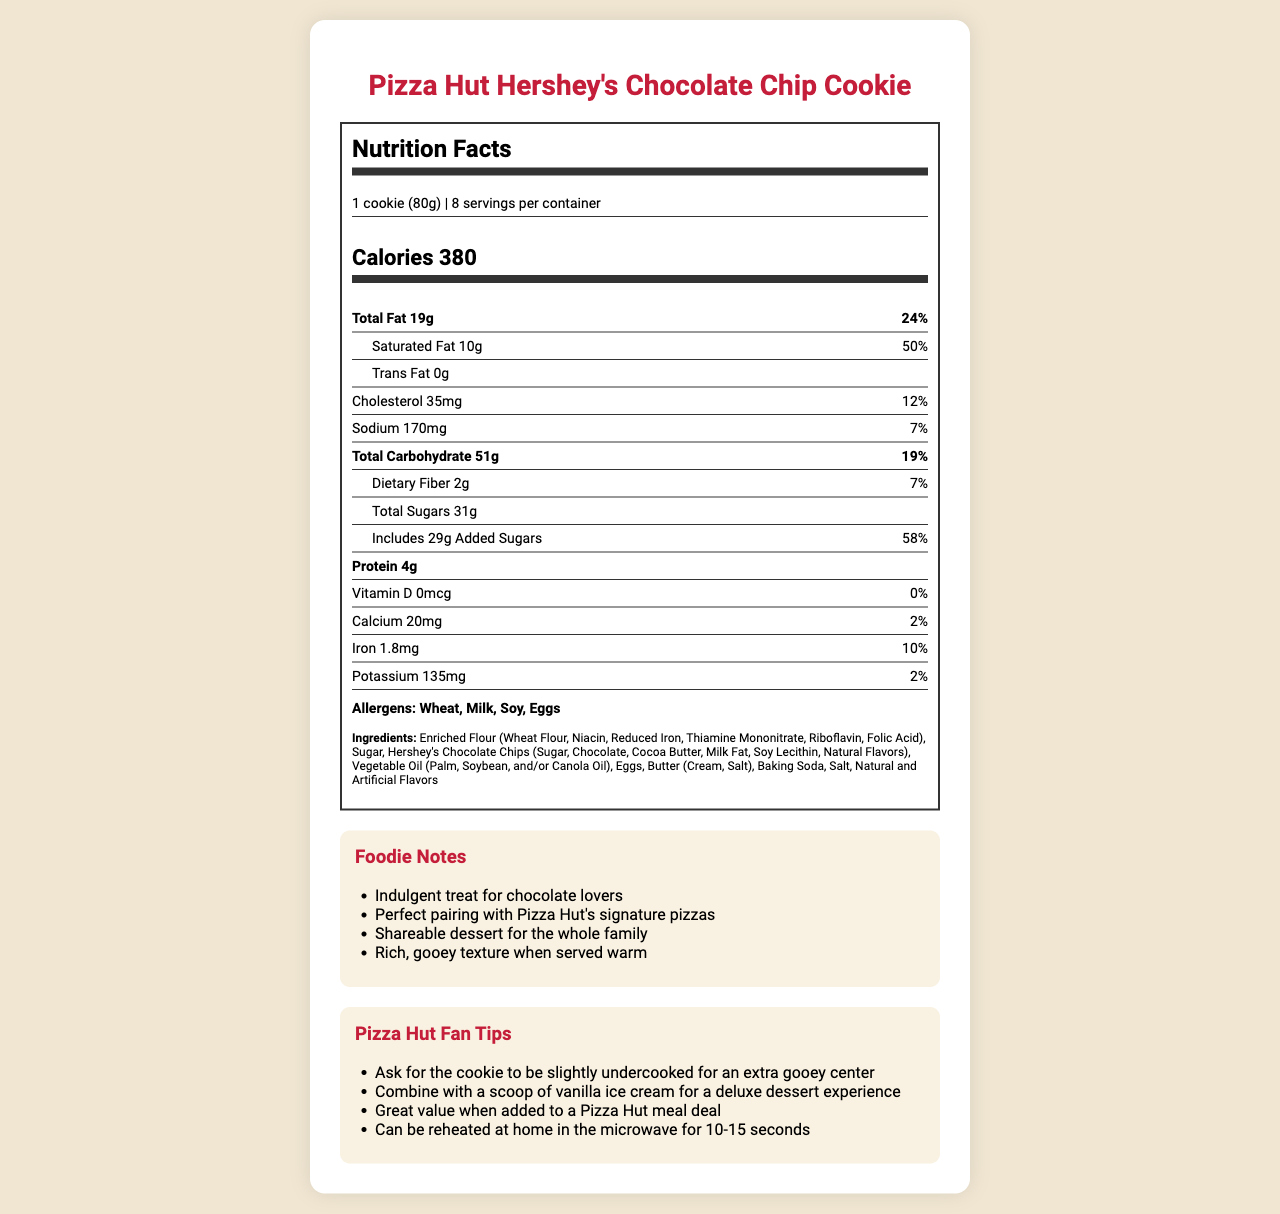what is the serving size for Pizza Hut Hershey's Chocolate Chip Cookie? The serving size is stated in the serving info section at the beginning of the document.
Answer: 1 cookie (80g) how many calories are in one serving of Pizza Hut Hershey's Chocolate Chip Cookie? The calorie information is prominently displayed below the serving size section.
Answer: 380 what is the total fat content in one serving? The total fat content is mentioned in the Total Fat nutrient info section.
Answer: 19g what percentage of the daily value is the saturated fat in one serving? The daily value percentage for saturated fat is listed right next to its amount under the Total Fat section.
Answer: 50% how much protein is in one serving of the cookie? The protein content is listed under the bold nutrient info section.
Answer: 4g what are the allergens listed for Pizza Hut Hershey's Chocolate Chip Cookie? The allergens are stated in the allergens section towards the bottom of the nutrition label.
Answer: Wheat, Milk, Soy, Eggs does the cookie contain any trans fat? The trans fat content is listed as 0g under the Total Fat section.
Answer: No could you list the ingredients used in this cookie? The ingredients are listed in the ingredients section towards the end of the document.
Answer: Enriched Flour (Wheat Flour, Niacin, Reduced Iron, Thiamine Mononitrate, Riboflavin, Folic Acid), Sugar, Hershey's Chocolate Chips (Sugar, Chocolate, Cocoa Butter, Milk Fat, Soy Lecithin, Natural Flavors), Vegetable Oil (Palm, Soybean, and/or Canola Oil), Eggs, Butter (Cream, Salt), Baking Soda, Salt, Natural and Artificial Flavors what is the recommended daily value for sodium in this cookie? A. 5% B. 7% C. 12% The daily value percentage for sodium is listed next to its amount under the nutrient info section.
Answer: B. 7% how many servings are there per container of this cookie? I. 6 II. 8 III. 10 IV. 12 The number of servings per container is mentioned in the serving info section at the beginning of the document.
Answer: II. 8 does the cookie contain any vitamin D? The vitamin D content is listed as 0mcg, with a daily value of 0% under the nutrient info section.
Answer: No what are some tips for enhancing the dessert experience with the cookie? These tips are mentioned in the Pizza Hut Fan Tips section at the end of the document.
Answer: Ask for the cookie to be slightly undercooked for an extra gooey center, Combine with a scoop of vanilla ice cream for a deluxe dessert experience, Great value when added to a Pizza Hut meal deal, Can be reheated at home in the microwave for 10-15 seconds summarize the key details of the document. The document gives detailed nutritional and ingredient information for the cookie, along with tips for enjoying it better.
Answer: The document is a comprehensive Nutrition Facts Label for Pizza Hut's Hershey's Chocolate Chip Cookie. It lists the nutritional information per serving, including calories, fats, cholesterol, sodium, carbohydrates, dietary fiber, sugars, protein, and various vitamins and minerals. It also highlights allergens and ingredients, and provides foodie notes and tips for enhancing the dessert experience. how much total sugar is in one serving, and how much of that is added sugars? The total sugar and added sugar content are listed under the sub-nutrient section of Total Carbohydrate.
Answer: Total sugar: 31g, Added sugars: 29g what is the main carbohydrate component listed in the ingredients? The main carbohydrate ingredient is the first ingredient listed.
Answer: Enriched Flour (Wheat Flour, Niacin, Reduced Iron, Thiamine Mononitrate, Riboflavin, Folic Acid) does this document include any nutritional information about dietary fiber? The dietary fiber content is listed under the sub-nutrient section of Total Carbohydrate.
Answer: Yes what is the potassium content in the cookie? The potassium content is listed towards the end of the nutrient info section.
Answer: 135mg how long should you reheat the cookie in the microwave for optimal results? Reheating instructions are given in the Pizza Hut Fan Tips section at the end of the document.
Answer: 10-15 seconds what is the net weight of the cookie according to the serving size? The serving size shows that one cookie weighs 80g.
Answer: 80g will consuming one serving of this cookie cover all your nutritional needs for vitamin D? The document shows that the cookie contains 0mcg of vitamin D, providing 0% of the daily recommended value.
Answer: No what other Pizza Hut item does the cookie pair well with according to the document? The foodie notes suggest the cookie pairs well with Pizza Hut's signature pizzas for a complete meal experience.
Answer: Pizza Hut's signature pizzas what's special about the cooking of the cookie for an extra gooey center? The fan tips mention asking for the cookie to be slightly undercooked to achieve an extra gooey center.
Answer: Ask for the cookie to be slightly undercooked what is the document's instruction for combining the cookie to make a deluxe dessert? The fan tips suggest pairing the cookie with vanilla ice cream for a deluxe dessert experience.
Answer: Combine with a scoop of vanilla ice cream is the cookie a gluten-free dessert option? The cookie contains wheat, as mentioned in the allergens and ingredients sections.
Answer: No can you determine the total amount of cholesterol in an entire container of cookies? The document only provides the cholesterol content for one serving, and it doesn’t state the total cholesterol content for the entire container.
Answer: Cannot be determined 